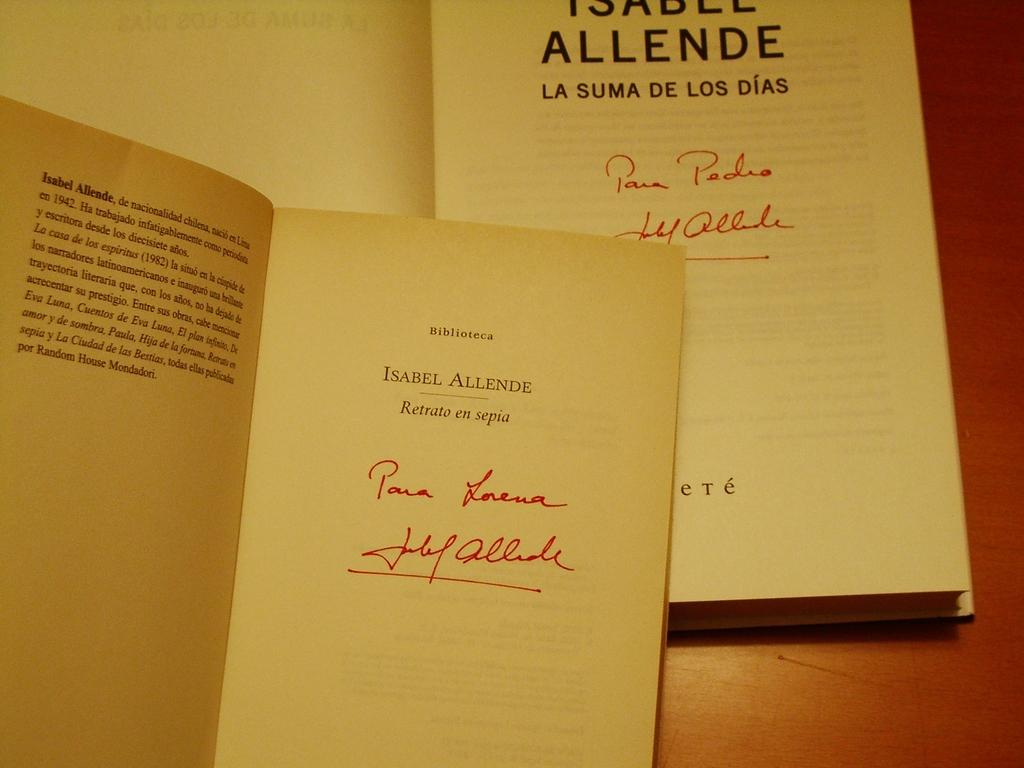<image>
Write a terse but informative summary of the picture. Book and booklet that includes Isabel Allende information 